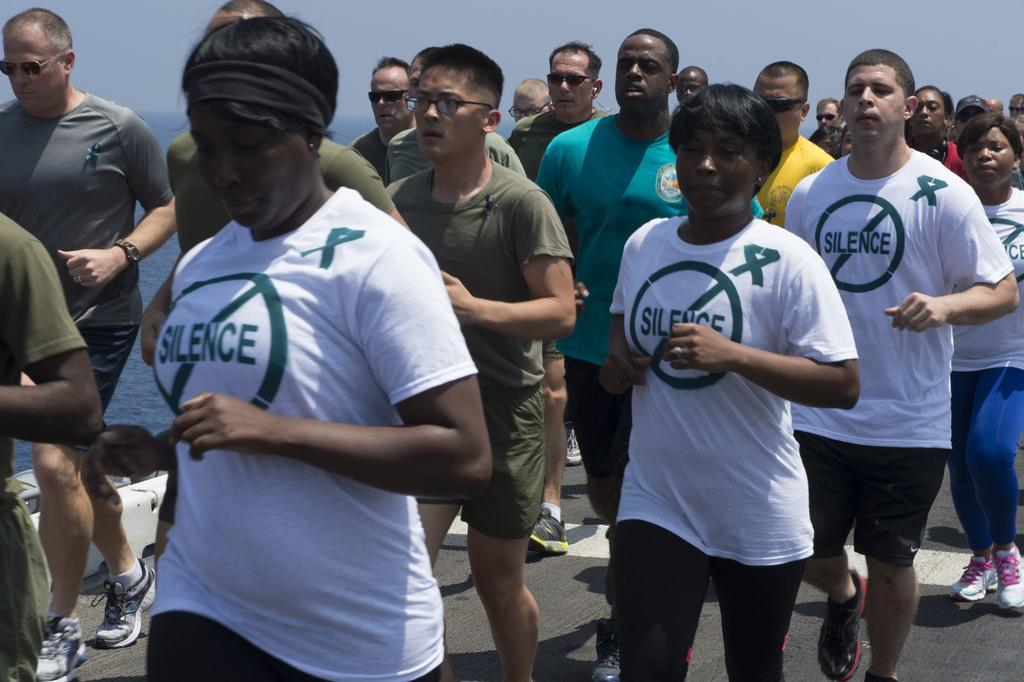What are the persons in the image doing? The persons in the image are jogging on the road. What can be seen in the background of the image? There is water and the sky visible in the background. What type of boot can be seen on the joggers' feet in the image? There is no boot visible on the joggers' feet in the image; they are likely wearing athletic shoes. How many folds can be seen in the sky in the image? There are no folds in the sky in the image; the sky is depicted as a continuous expanse. 